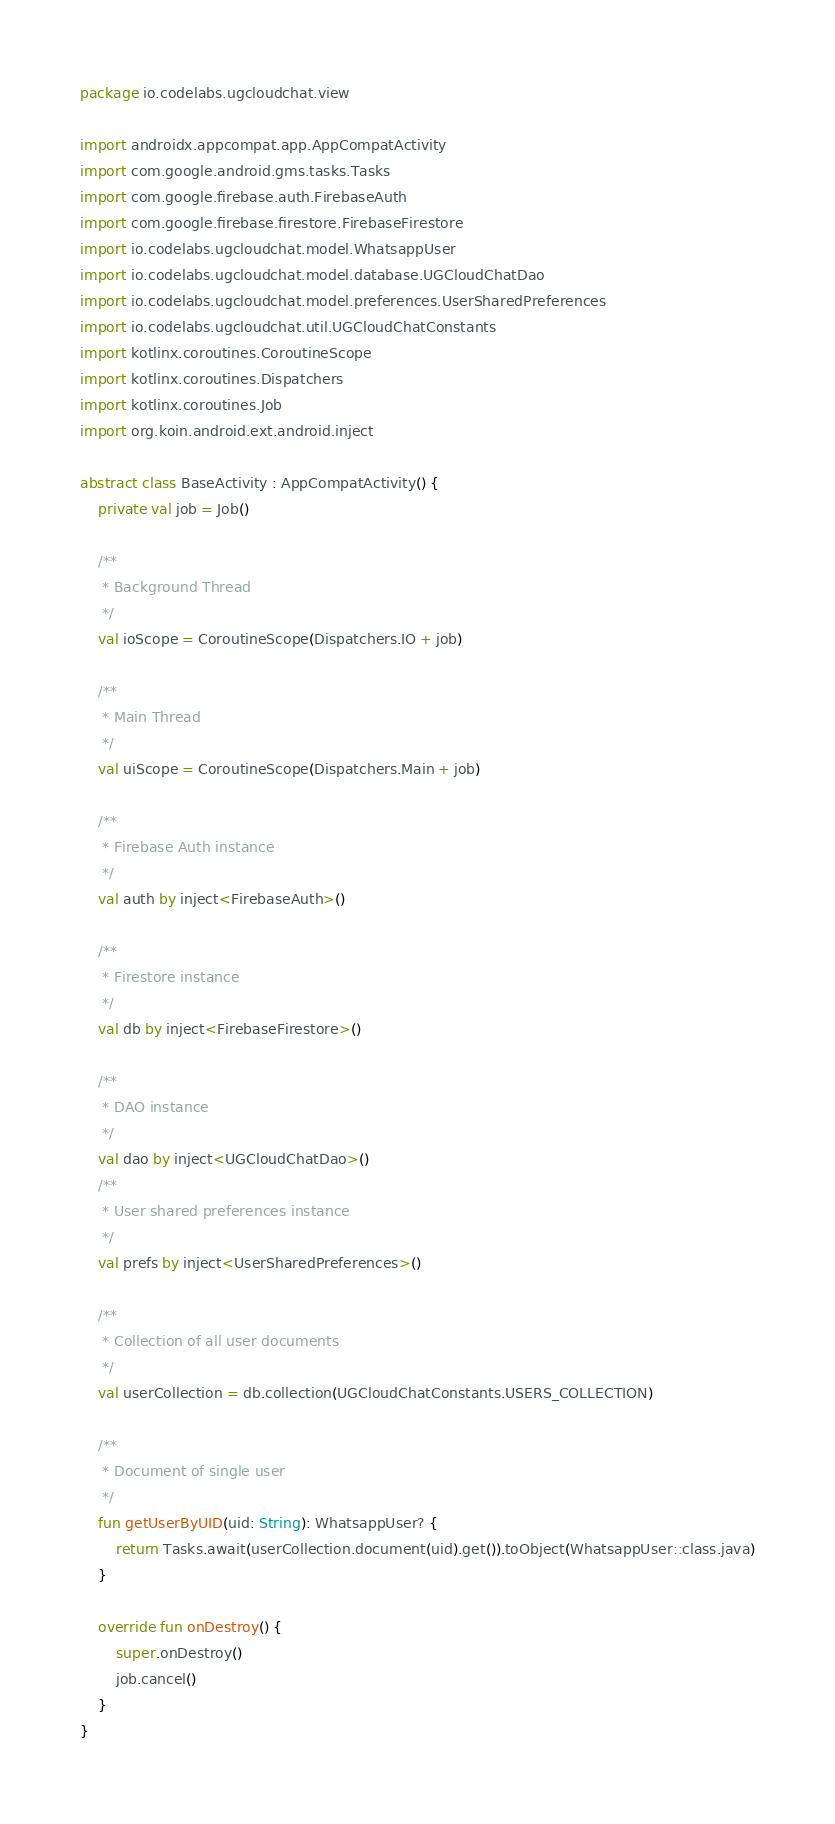<code> <loc_0><loc_0><loc_500><loc_500><_Kotlin_>package io.codelabs.ugcloudchat.view

import androidx.appcompat.app.AppCompatActivity
import com.google.android.gms.tasks.Tasks
import com.google.firebase.auth.FirebaseAuth
import com.google.firebase.firestore.FirebaseFirestore
import io.codelabs.ugcloudchat.model.WhatsappUser
import io.codelabs.ugcloudchat.model.database.UGCloudChatDao
import io.codelabs.ugcloudchat.model.preferences.UserSharedPreferences
import io.codelabs.ugcloudchat.util.UGCloudChatConstants
import kotlinx.coroutines.CoroutineScope
import kotlinx.coroutines.Dispatchers
import kotlinx.coroutines.Job
import org.koin.android.ext.android.inject

abstract class BaseActivity : AppCompatActivity() {
    private val job = Job()

    /**
     * Background Thread
     */
    val ioScope = CoroutineScope(Dispatchers.IO + job)

    /**
     * Main Thread
     */
    val uiScope = CoroutineScope(Dispatchers.Main + job)

    /**
     * Firebase Auth instance
     */
    val auth by inject<FirebaseAuth>()

    /**
     * Firestore instance
     */
    val db by inject<FirebaseFirestore>()

    /**
     * DAO instance
     */
    val dao by inject<UGCloudChatDao>()
    /**
     * User shared preferences instance
     */
    val prefs by inject<UserSharedPreferences>()

    /**
     * Collection of all user documents
     */
    val userCollection = db.collection(UGCloudChatConstants.USERS_COLLECTION)

    /**
     * Document of single user
     */
    fun getUserByUID(uid: String): WhatsappUser? {
        return Tasks.await(userCollection.document(uid).get()).toObject(WhatsappUser::class.java)
    }

    override fun onDestroy() {
        super.onDestroy()
        job.cancel()
    }
}</code> 